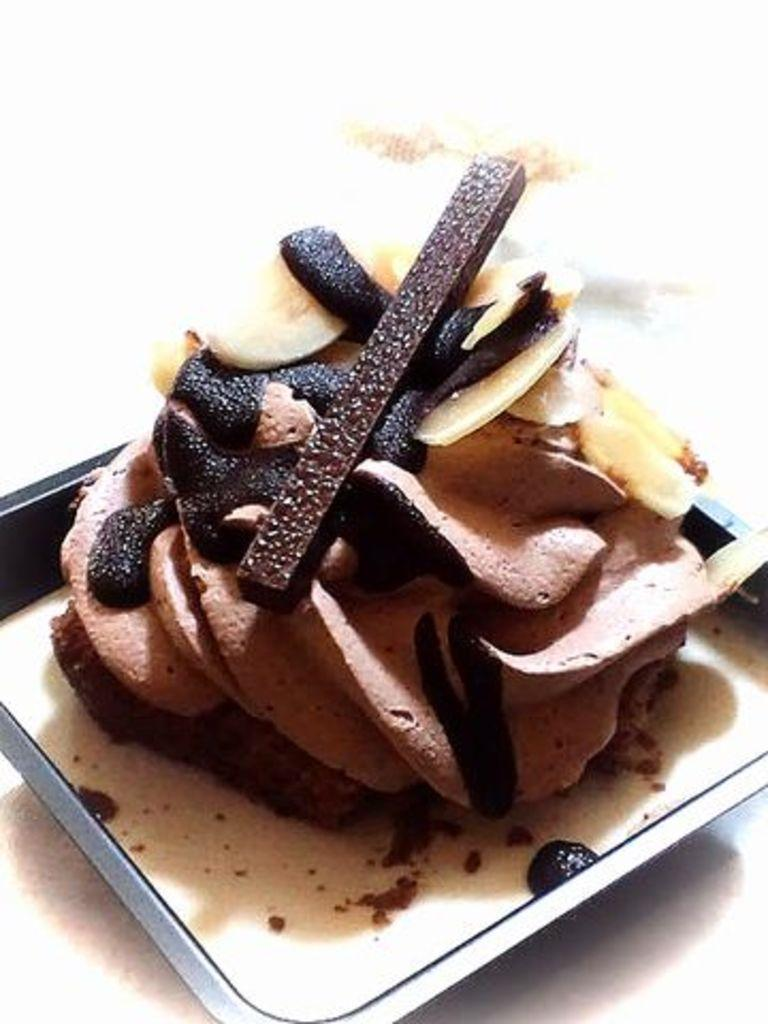What is the color of the tray in the image? There is a black tray in the image. What is on the tray? There is chocolate cream and chocolate pieces on the tray. How many friends are visible in the image? There are no friends visible in the image; it only features a black tray with chocolate cream and chocolate pieces. What type of trucks are used to transport the chocolate cream in the image? There is no reference to trucks or the transportation of the chocolate cream in the image. 